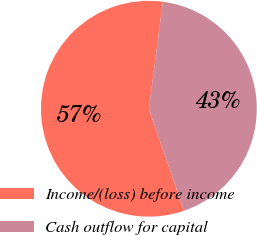Convert chart. <chart><loc_0><loc_0><loc_500><loc_500><pie_chart><fcel>Income/(loss) before income<fcel>Cash outflow for capital<nl><fcel>57.34%<fcel>42.66%<nl></chart> 